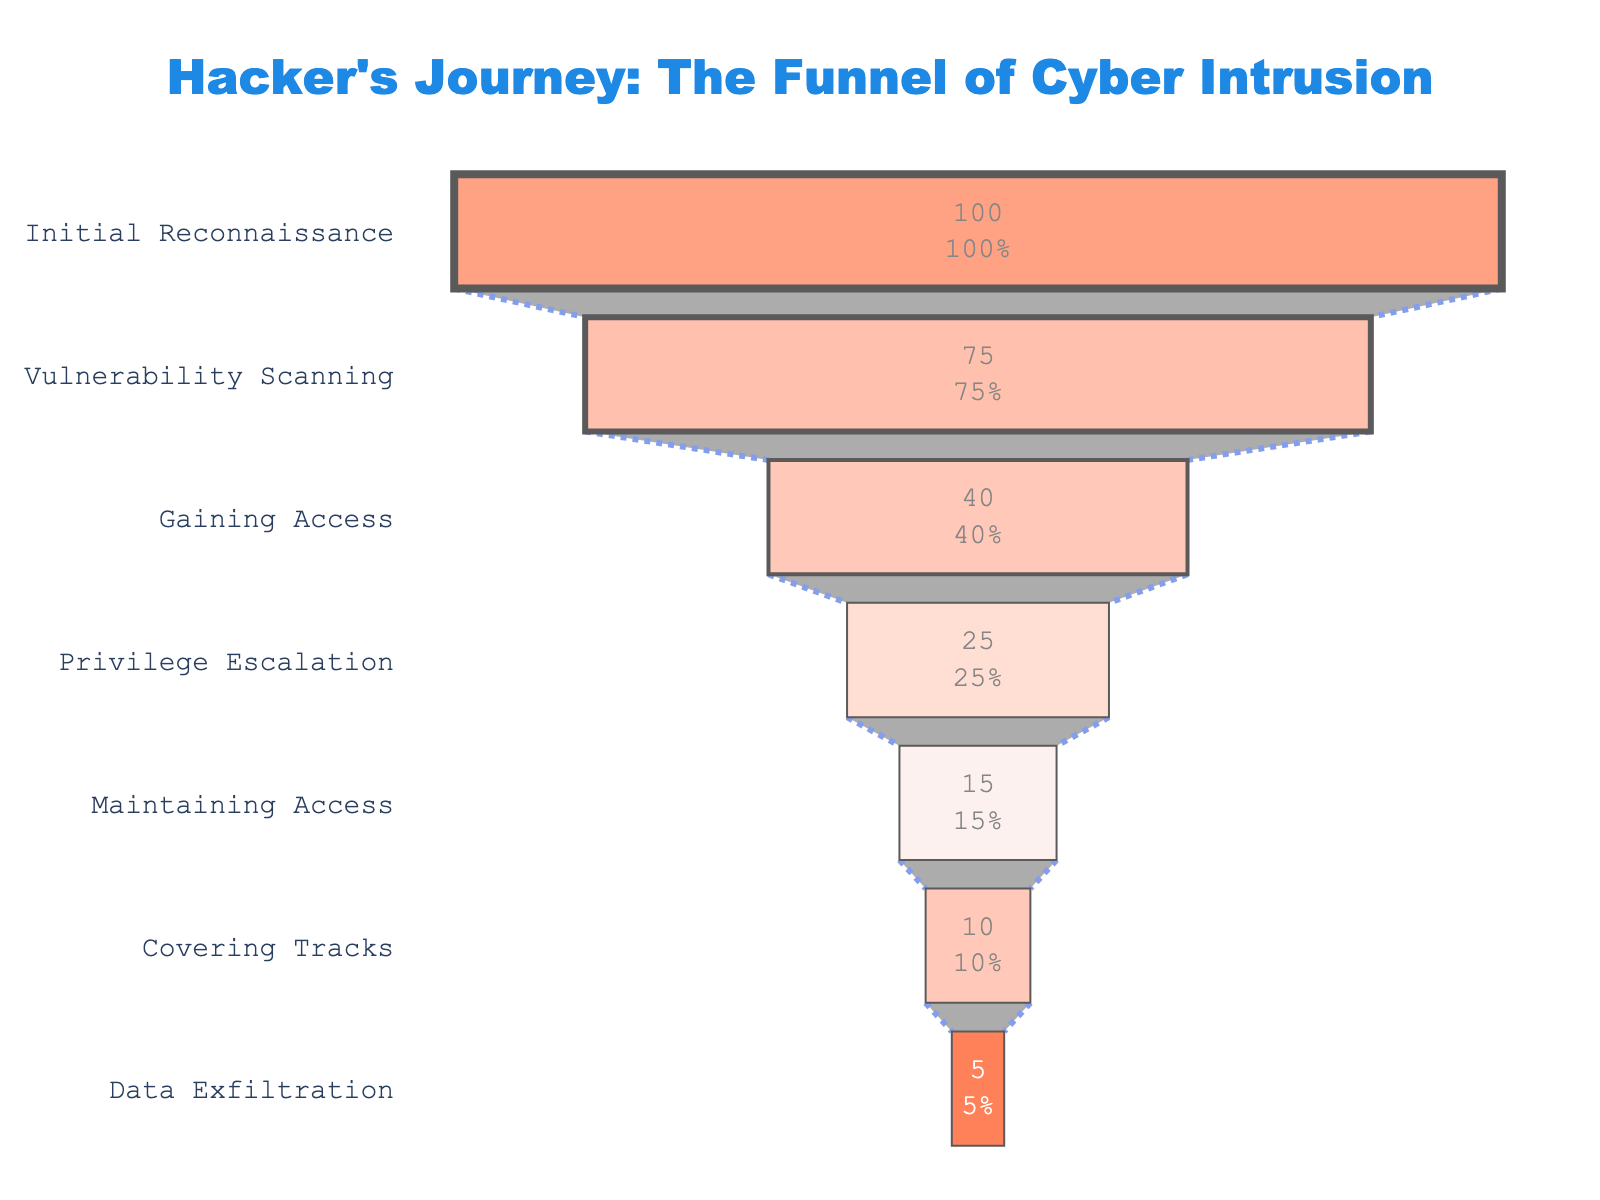What stage has the highest percentage of hackers progressing through? The figure shows that the "Initial Reconnaissance" stage has the highest percentage, at 100%.
Answer: Initial Reconnaissance How many stages are depicted in the funnel chart? The figure lists the stages vertically, and counting them shows there are 7 stages in total.
Answer: 7 What is the percentage drop from "Initial Reconnaissance" to "Vulnerability Scanning"? The percentage for "Initial Reconnaissance" is 100% and for "Vulnerability Scanning" is 75%. Subtracting these gives 100% - 75% = 25%.
Answer: 25% Which stage has a percentage of 15%? The stage with 15% is "Maintaining Access," as clearly shown next to the stage label in the chart.
Answer: Maintaining Access What is the percentage difference between "Gaining Access" and "Covering Tracks"? "Gaining Access" has 40%, and "Covering Tracks" has 10%. So the difference is 40% - 10% = 30%.
Answer: 30% What's the combined percentage of hackers who make it past the "Privilege Escalation" stage? Adding the percentages of stages past "Privilege Escalation" gives 15% (Maintaining Access) + 10% (Covering Tracks) + 5% (Data Exfiltration) = 30%.
Answer: 30% Which stage has the lowest percentage of hackers progressing through? The figure shows the lowest percentage, 5%, at the "Data Exfiltration" stage.
Answer: Data Exfiltration Compare the percentage drop from "Gaining Access" to "Privilege Escalation" with the drop from "Privilege Escalation" to "Maintaining Access". Which is larger? From "Gaining Access" (40%) to "Privilege Escalation" (25%), the drop is 40% - 25% = 15%. From "Privilege Escalation" (25%) to "Maintaining Access" (15%), the drop is 25% - 15% = 10%. So, the larger drop is from "Gaining Access" to "Privilege Escalation".
Answer: From "Gaining Access" to "Privilege Escalation" What is the average percentage of hackers progressing through the first three stages? The first three stages are "Initial Reconnaissance" (100%), "Vulnerability Scanning" (75%), and "Gaining Access" (40%). The average is (100% + 75% + 40%) / 3 = 215% / 3 ≈ 71.67%.
Answer: 71.67% Which stages show a percentage of less than 20%? Reviewing the percentages in the chart, the stages with less than 20% are "Maintaining Access" (15%), "Covering Tracks" (10%), and "Data Exfiltration" (5%).
Answer: Maintaining Access, Covering Tracks, Data Exfiltration 